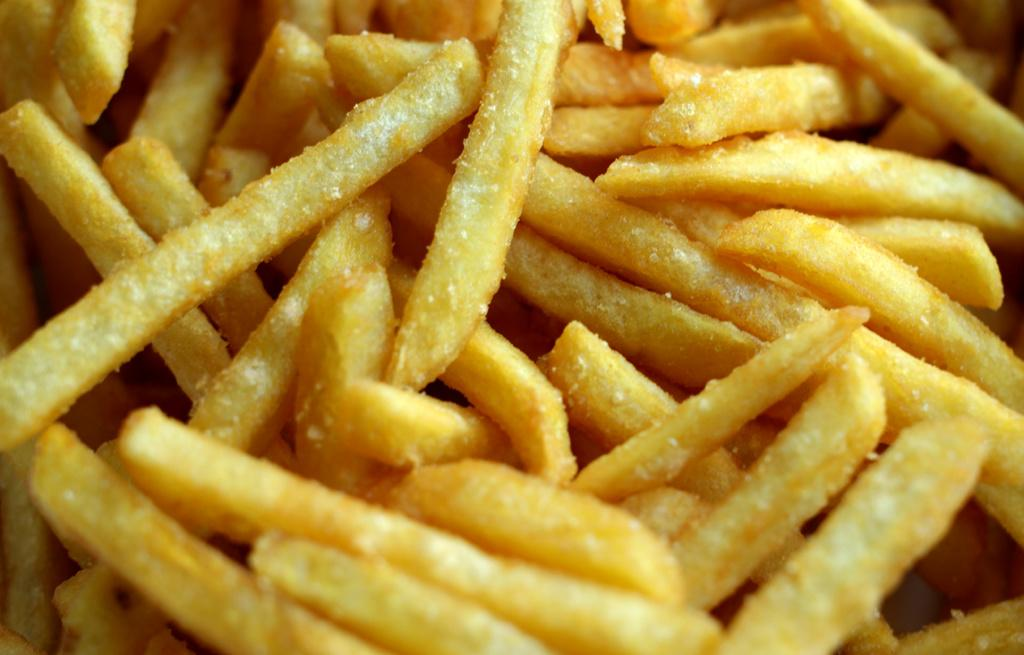What type of food is visible in the image? There are fried chips in the image. What color is the shirt worn by the key in the image? There is no shirt or key present in the image; it only features fried chips. 